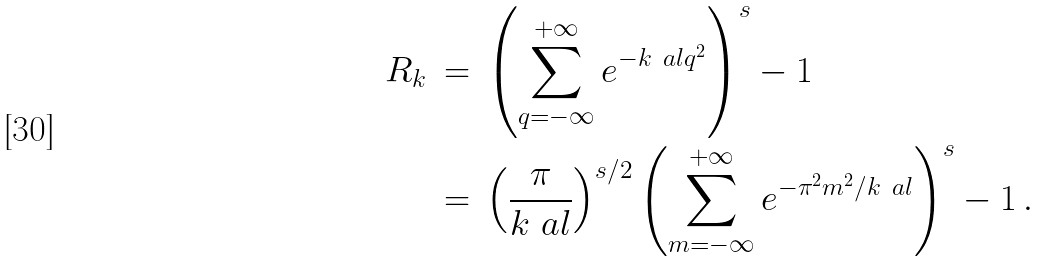Convert formula to latex. <formula><loc_0><loc_0><loc_500><loc_500>R _ { k } & \, = \, \left ( \sum _ { q = - \infty } ^ { + \infty } e ^ { - k \ a l q ^ { 2 } } \right ) ^ { s } - 1 \\ & \, = \, \left ( \frac { \pi } { k \ a l } \right ) ^ { s / 2 } \left ( \sum _ { m = - \infty } ^ { + \infty } e ^ { - \pi ^ { 2 } m ^ { 2 } / k \ a l } \right ) ^ { s } - 1 \, .</formula> 